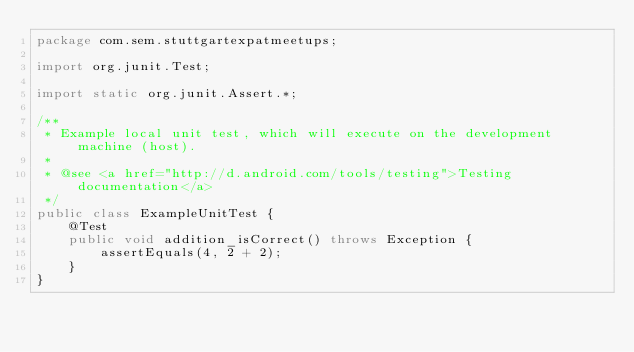<code> <loc_0><loc_0><loc_500><loc_500><_Java_>package com.sem.stuttgartexpatmeetups;

import org.junit.Test;

import static org.junit.Assert.*;

/**
 * Example local unit test, which will execute on the development machine (host).
 *
 * @see <a href="http://d.android.com/tools/testing">Testing documentation</a>
 */
public class ExampleUnitTest {
    @Test
    public void addition_isCorrect() throws Exception {
        assertEquals(4, 2 + 2);
    }
}</code> 